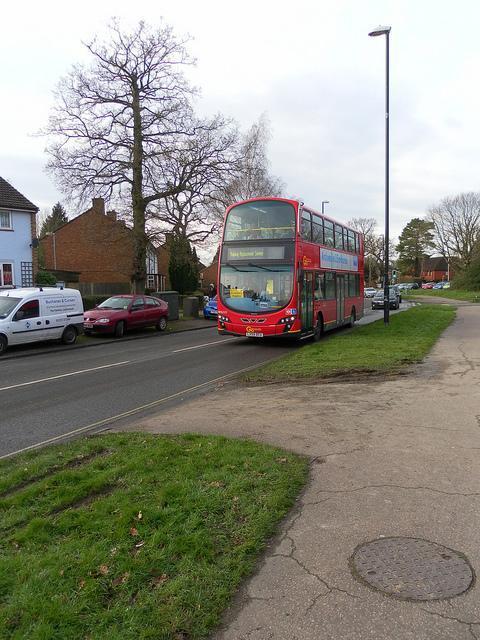How many levels to the bus?
Give a very brief answer. 2. How many cars are there?
Give a very brief answer. 2. 